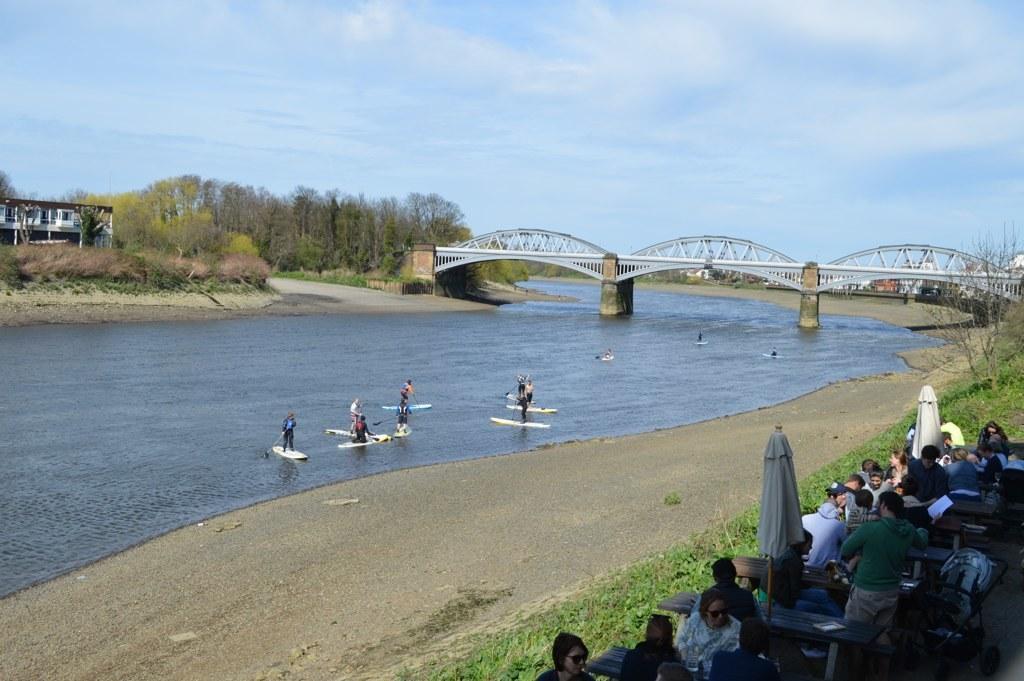In one or two sentences, can you explain what this image depicts? In this image, there are a few people. Among them, some people are standing on skateboards on the top of the water. We can see some tables with objects. We can see some poles with cloth. We can see some grass, plants and trees. We can also see a house. We can see the bridge above the water. We can also see the sky with clouds. We can see the ground. 